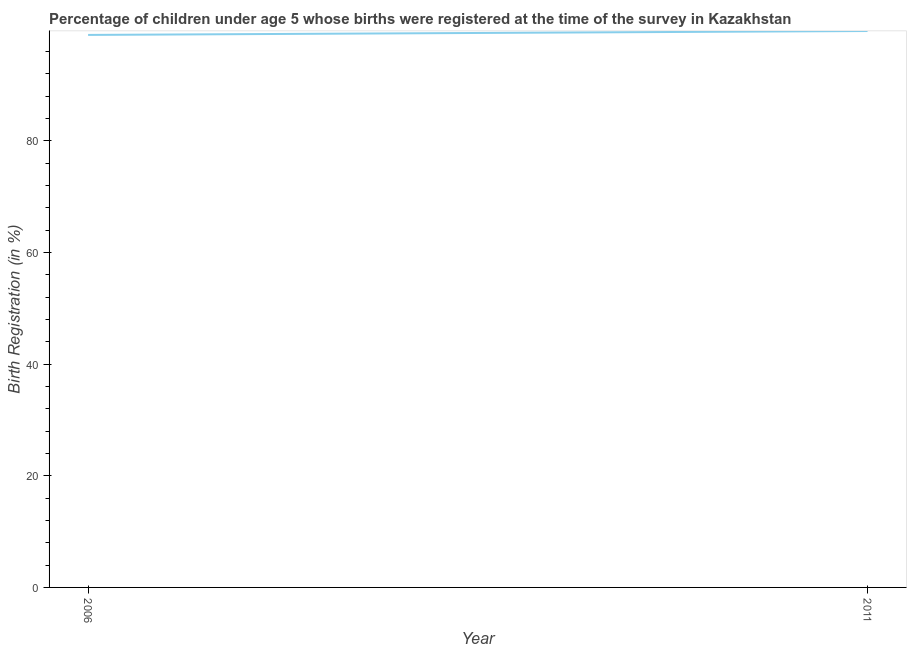What is the birth registration in 2011?
Provide a succinct answer. 99.7. Across all years, what is the maximum birth registration?
Offer a terse response. 99.7. In which year was the birth registration maximum?
Your answer should be compact. 2011. In which year was the birth registration minimum?
Offer a very short reply. 2006. What is the sum of the birth registration?
Provide a succinct answer. 198.7. What is the difference between the birth registration in 2006 and 2011?
Keep it short and to the point. -0.7. What is the average birth registration per year?
Keep it short and to the point. 99.35. What is the median birth registration?
Make the answer very short. 99.35. Do a majority of the years between 2006 and 2011 (inclusive) have birth registration greater than 88 %?
Provide a succinct answer. Yes. What is the ratio of the birth registration in 2006 to that in 2011?
Your answer should be compact. 0.99. Is the birth registration in 2006 less than that in 2011?
Make the answer very short. Yes. How many lines are there?
Your answer should be very brief. 1. How many years are there in the graph?
Your answer should be compact. 2. Does the graph contain any zero values?
Provide a succinct answer. No. Does the graph contain grids?
Your response must be concise. No. What is the title of the graph?
Provide a short and direct response. Percentage of children under age 5 whose births were registered at the time of the survey in Kazakhstan. What is the label or title of the X-axis?
Provide a succinct answer. Year. What is the label or title of the Y-axis?
Ensure brevity in your answer.  Birth Registration (in %). What is the Birth Registration (in %) in 2006?
Offer a very short reply. 99. What is the Birth Registration (in %) of 2011?
Give a very brief answer. 99.7. 